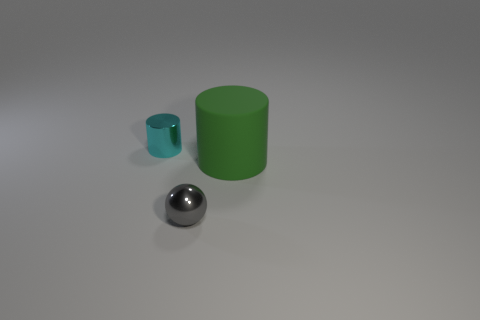Add 2 purple metallic cylinders. How many objects exist? 5 Subtract all gray blocks. How many cyan cylinders are left? 1 Subtract all purple metal balls. Subtract all large cylinders. How many objects are left? 2 Add 3 gray objects. How many gray objects are left? 4 Add 1 spheres. How many spheres exist? 2 Subtract all green cylinders. How many cylinders are left? 1 Subtract 0 purple cylinders. How many objects are left? 3 Subtract all spheres. How many objects are left? 2 Subtract all green spheres. Subtract all brown cubes. How many spheres are left? 1 